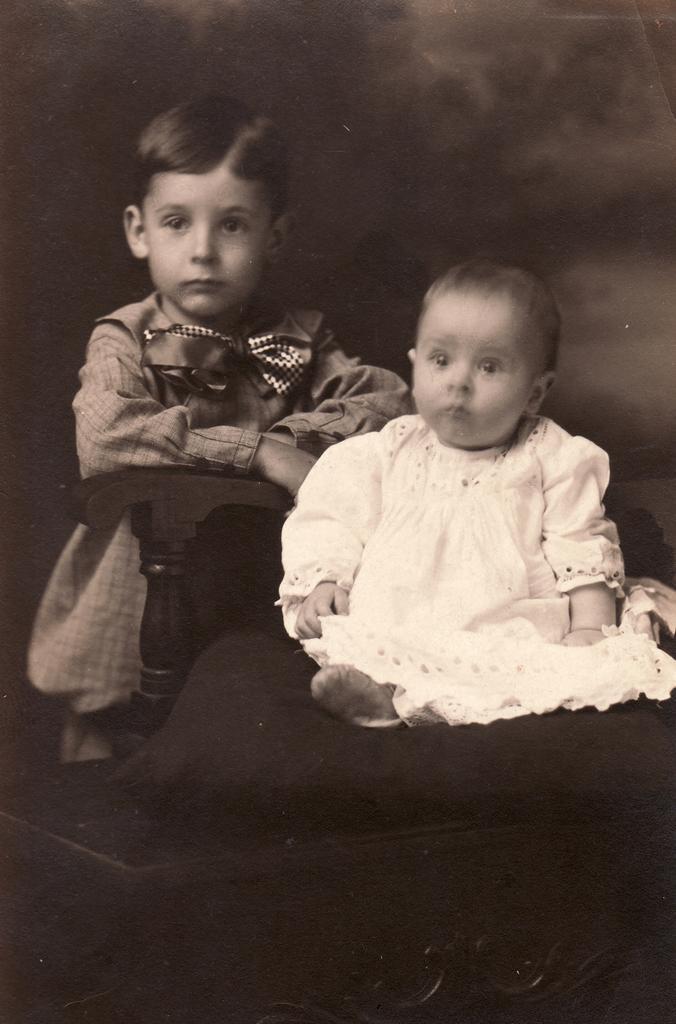Can you describe this image briefly? In this picture we can see two kids and a chair. 